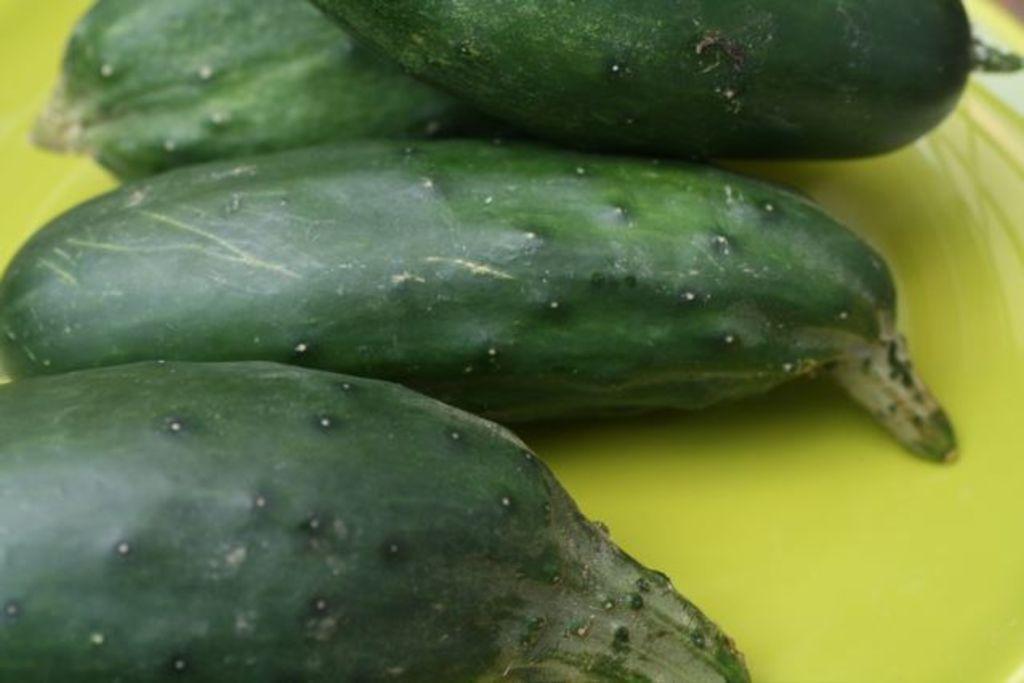Could you give a brief overview of what you see in this image? In the image we can see a vegetable and a plate which is in parrot green color and the vegetable is in dark green color. 